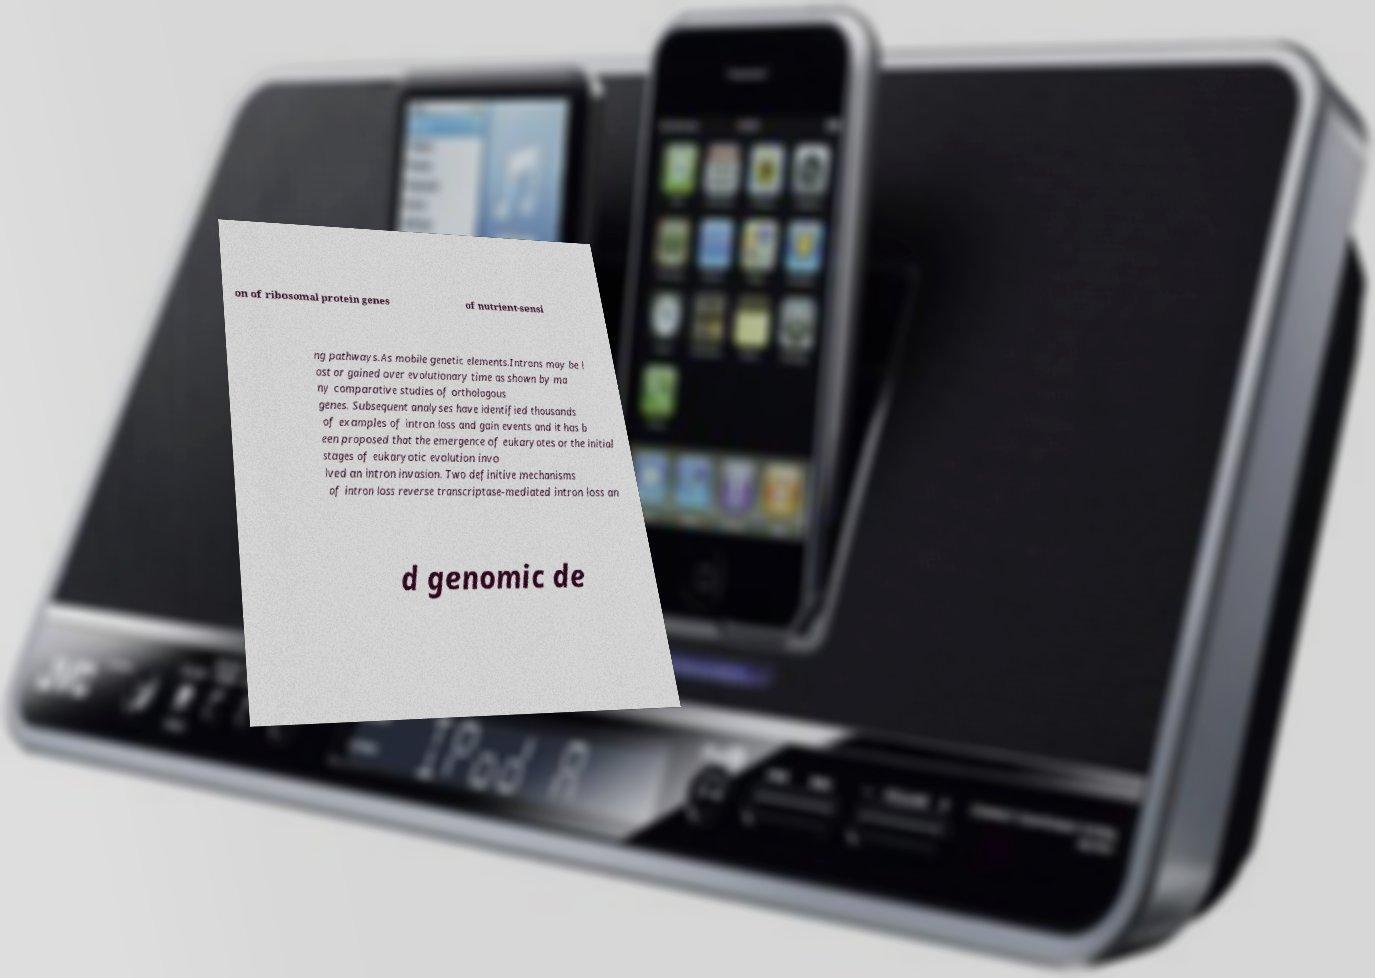What messages or text are displayed in this image? I need them in a readable, typed format. on of ribosomal protein genes of nutrient-sensi ng pathways.As mobile genetic elements.Introns may be l ost or gained over evolutionary time as shown by ma ny comparative studies of orthologous genes. Subsequent analyses have identified thousands of examples of intron loss and gain events and it has b een proposed that the emergence of eukaryotes or the initial stages of eukaryotic evolution invo lved an intron invasion. Two definitive mechanisms of intron loss reverse transcriptase-mediated intron loss an d genomic de 